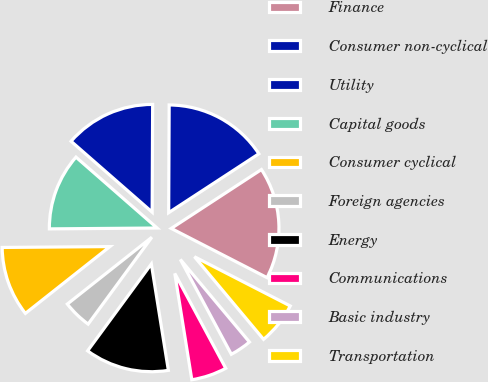Convert chart to OTSL. <chart><loc_0><loc_0><loc_500><loc_500><pie_chart><fcel>Finance<fcel>Consumer non-cyclical<fcel>Utility<fcel>Capital goods<fcel>Consumer cyclical<fcel>Foreign agencies<fcel>Energy<fcel>Communications<fcel>Basic industry<fcel>Transportation<nl><fcel>16.76%<fcel>15.72%<fcel>13.64%<fcel>11.56%<fcel>10.52%<fcel>4.28%<fcel>12.6%<fcel>5.32%<fcel>3.24%<fcel>6.36%<nl></chart> 